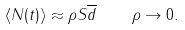Convert formula to latex. <formula><loc_0><loc_0><loc_500><loc_500>\langle N ( t ) \rangle \approx \rho S \overline { d } \quad \rho \rightarrow 0 .</formula> 